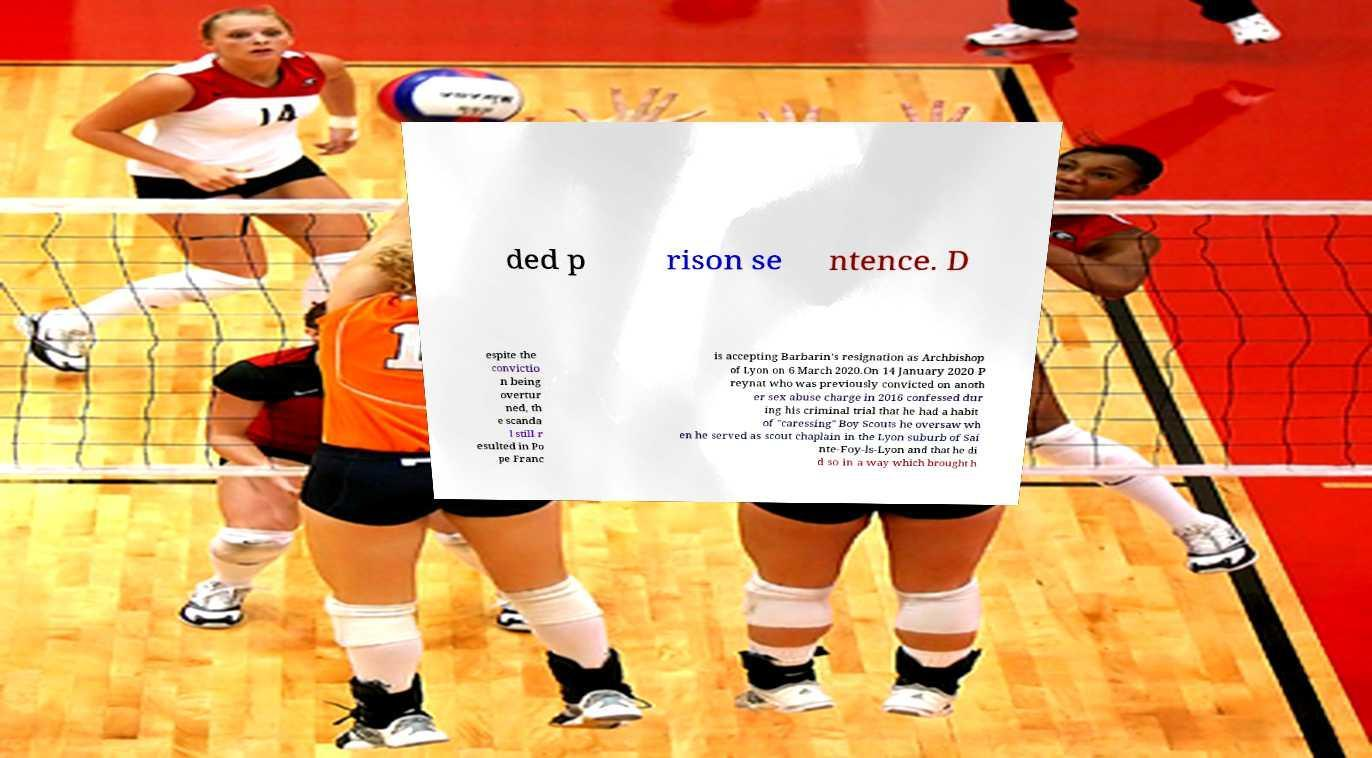Please identify and transcribe the text found in this image. ded p rison se ntence. D espite the convictio n being overtur ned, th e scanda l still r esulted in Po pe Franc is accepting Barbarin's resignation as Archbishop of Lyon on 6 March 2020.On 14 January 2020 P reynat who was previously convicted on anoth er sex abuse charge in 2016 confessed dur ing his criminal trial that he had a habit of "caressing" Boy Scouts he oversaw wh en he served as scout chaplain in the Lyon suburb of Sai nte-Foy-ls-Lyon and that he di d so in a way which brought h 